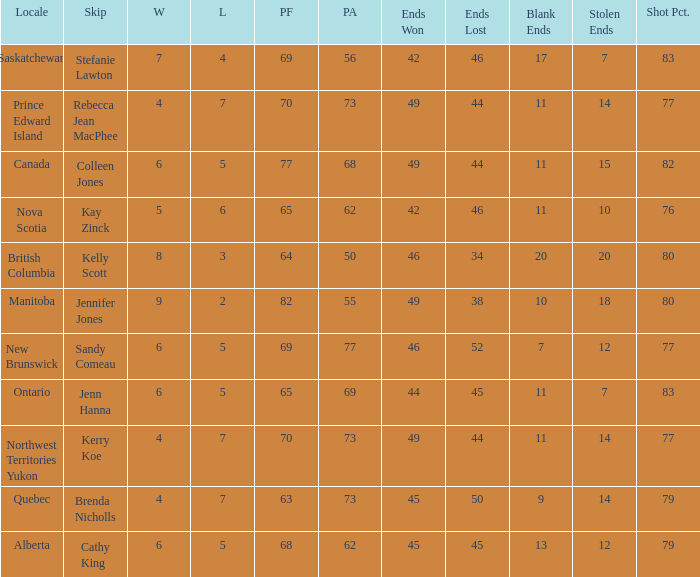What is the PA when the PF is 77? 68.0. 